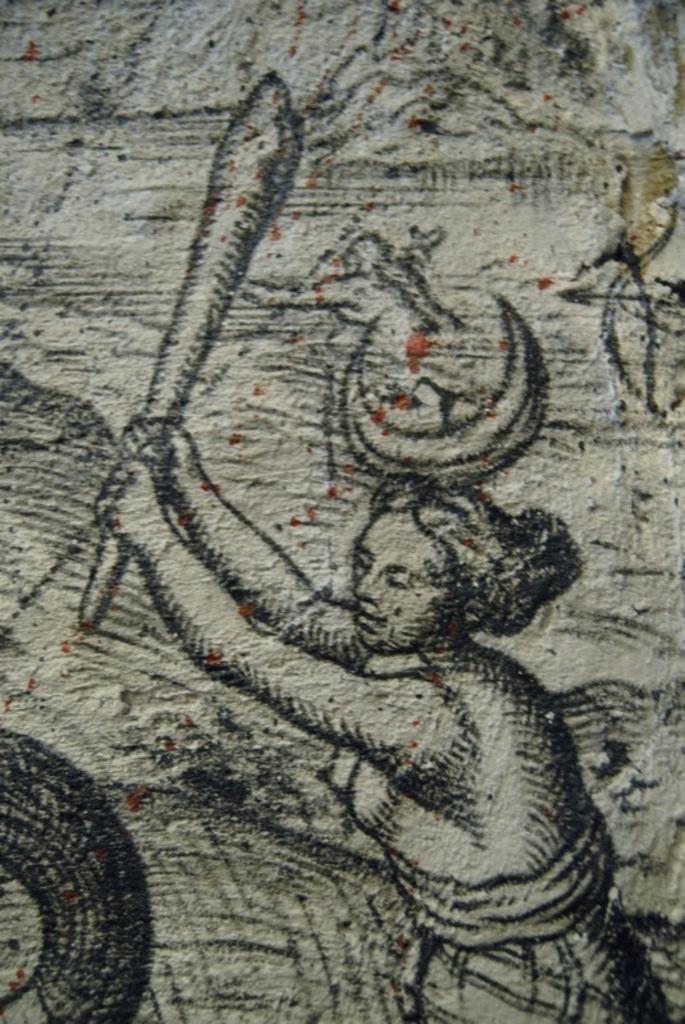Please provide a concise description of this image. As we can see in the image there is a wall. On wall there is a woman painting. 